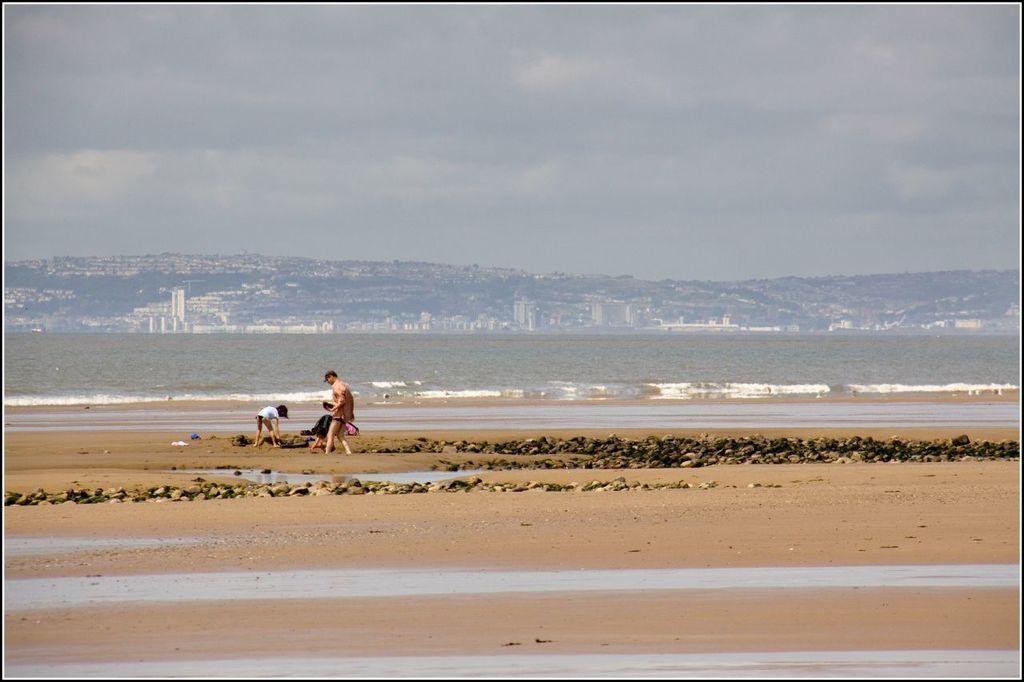Can you describe this image briefly? In this picture there is a man who is wearing t-shirt and shorts, both of them standing on the beach. Here we can see many stones. In the background we can see buildings, trees and mountain. Here we can see river. On the top we can see sky and clouds. 